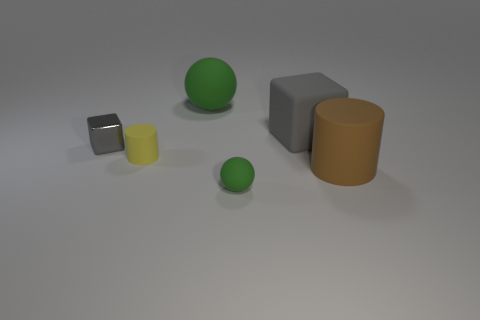Add 1 big gray rubber blocks. How many objects exist? 7 Subtract all spheres. How many objects are left? 4 Subtract all tiny gray things. Subtract all tiny rubber balls. How many objects are left? 4 Add 3 gray shiny objects. How many gray shiny objects are left? 4 Add 4 small brown metallic objects. How many small brown metallic objects exist? 4 Subtract 0 blue blocks. How many objects are left? 6 